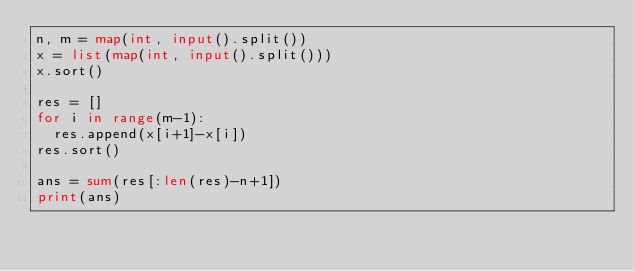Convert code to text. <code><loc_0><loc_0><loc_500><loc_500><_Python_>n, m = map(int, input().split())
x = list(map(int, input().split()))
x.sort()

res = []
for i in range(m-1):
  res.append(x[i+1]-x[i])
res.sort()

ans = sum(res[:len(res)-n+1])
print(ans)</code> 